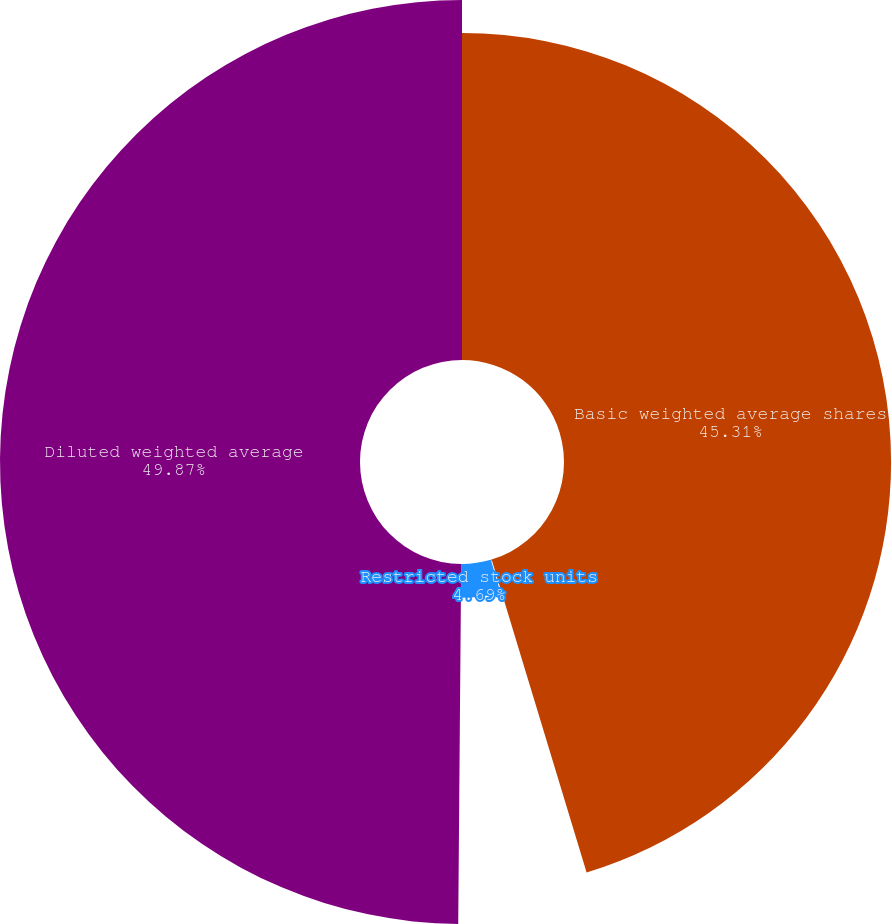<chart> <loc_0><loc_0><loc_500><loc_500><pie_chart><fcel>Basic weighted average shares<fcel>Stock options<fcel>Restricted stock units<fcel>Diluted weighted average<nl><fcel>45.31%<fcel>0.13%<fcel>4.69%<fcel>49.87%<nl></chart> 